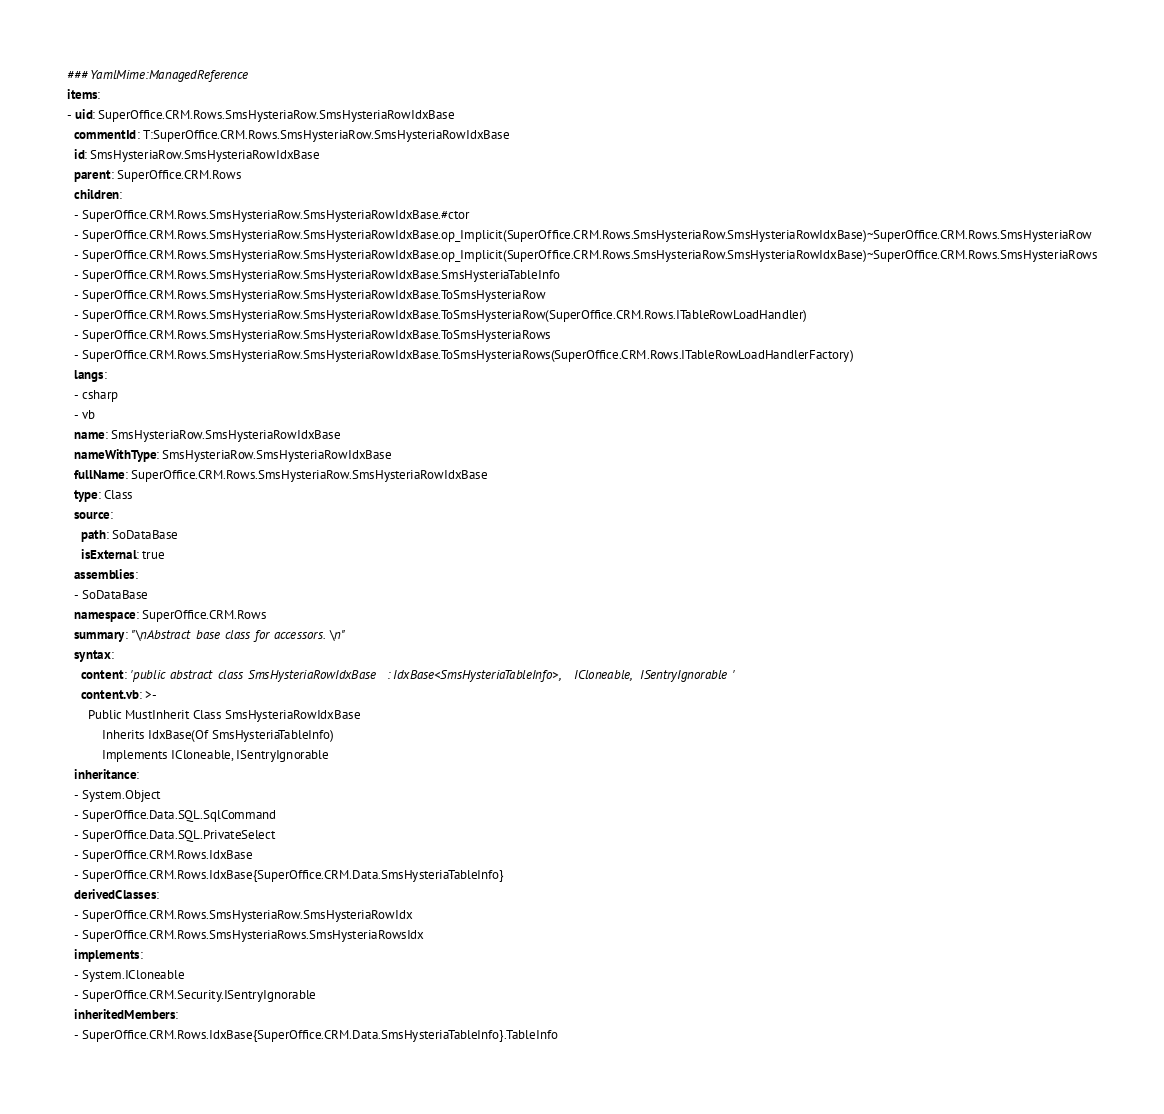<code> <loc_0><loc_0><loc_500><loc_500><_YAML_>### YamlMime:ManagedReference
items:
- uid: SuperOffice.CRM.Rows.SmsHysteriaRow.SmsHysteriaRowIdxBase
  commentId: T:SuperOffice.CRM.Rows.SmsHysteriaRow.SmsHysteriaRowIdxBase
  id: SmsHysteriaRow.SmsHysteriaRowIdxBase
  parent: SuperOffice.CRM.Rows
  children:
  - SuperOffice.CRM.Rows.SmsHysteriaRow.SmsHysteriaRowIdxBase.#ctor
  - SuperOffice.CRM.Rows.SmsHysteriaRow.SmsHysteriaRowIdxBase.op_Implicit(SuperOffice.CRM.Rows.SmsHysteriaRow.SmsHysteriaRowIdxBase)~SuperOffice.CRM.Rows.SmsHysteriaRow
  - SuperOffice.CRM.Rows.SmsHysteriaRow.SmsHysteriaRowIdxBase.op_Implicit(SuperOffice.CRM.Rows.SmsHysteriaRow.SmsHysteriaRowIdxBase)~SuperOffice.CRM.Rows.SmsHysteriaRows
  - SuperOffice.CRM.Rows.SmsHysteriaRow.SmsHysteriaRowIdxBase.SmsHysteriaTableInfo
  - SuperOffice.CRM.Rows.SmsHysteriaRow.SmsHysteriaRowIdxBase.ToSmsHysteriaRow
  - SuperOffice.CRM.Rows.SmsHysteriaRow.SmsHysteriaRowIdxBase.ToSmsHysteriaRow(SuperOffice.CRM.Rows.ITableRowLoadHandler)
  - SuperOffice.CRM.Rows.SmsHysteriaRow.SmsHysteriaRowIdxBase.ToSmsHysteriaRows
  - SuperOffice.CRM.Rows.SmsHysteriaRow.SmsHysteriaRowIdxBase.ToSmsHysteriaRows(SuperOffice.CRM.Rows.ITableRowLoadHandlerFactory)
  langs:
  - csharp
  - vb
  name: SmsHysteriaRow.SmsHysteriaRowIdxBase
  nameWithType: SmsHysteriaRow.SmsHysteriaRowIdxBase
  fullName: SuperOffice.CRM.Rows.SmsHysteriaRow.SmsHysteriaRowIdxBase
  type: Class
  source:
    path: SoDataBase
    isExternal: true
  assemblies:
  - SoDataBase
  namespace: SuperOffice.CRM.Rows
  summary: "\nAbstract base class for accessors.\n"
  syntax:
    content: 'public abstract class SmsHysteriaRowIdxBase : IdxBase<SmsHysteriaTableInfo>, ICloneable, ISentryIgnorable'
    content.vb: >-
      Public MustInherit Class SmsHysteriaRowIdxBase
          Inherits IdxBase(Of SmsHysteriaTableInfo)
          Implements ICloneable, ISentryIgnorable
  inheritance:
  - System.Object
  - SuperOffice.Data.SQL.SqlCommand
  - SuperOffice.Data.SQL.PrivateSelect
  - SuperOffice.CRM.Rows.IdxBase
  - SuperOffice.CRM.Rows.IdxBase{SuperOffice.CRM.Data.SmsHysteriaTableInfo}
  derivedClasses:
  - SuperOffice.CRM.Rows.SmsHysteriaRow.SmsHysteriaRowIdx
  - SuperOffice.CRM.Rows.SmsHysteriaRows.SmsHysteriaRowsIdx
  implements:
  - System.ICloneable
  - SuperOffice.CRM.Security.ISentryIgnorable
  inheritedMembers:
  - SuperOffice.CRM.Rows.IdxBase{SuperOffice.CRM.Data.SmsHysteriaTableInfo}.TableInfo</code> 